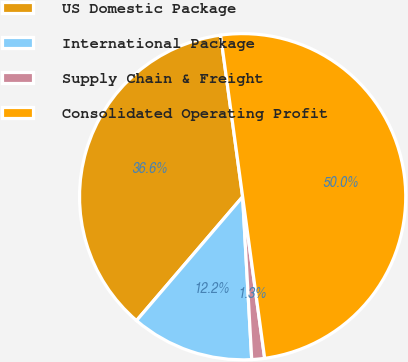Convert chart to OTSL. <chart><loc_0><loc_0><loc_500><loc_500><pie_chart><fcel>US Domestic Package<fcel>International Package<fcel>Supply Chain & Freight<fcel>Consolidated Operating Profit<nl><fcel>36.57%<fcel>12.16%<fcel>1.27%<fcel>50.0%<nl></chart> 